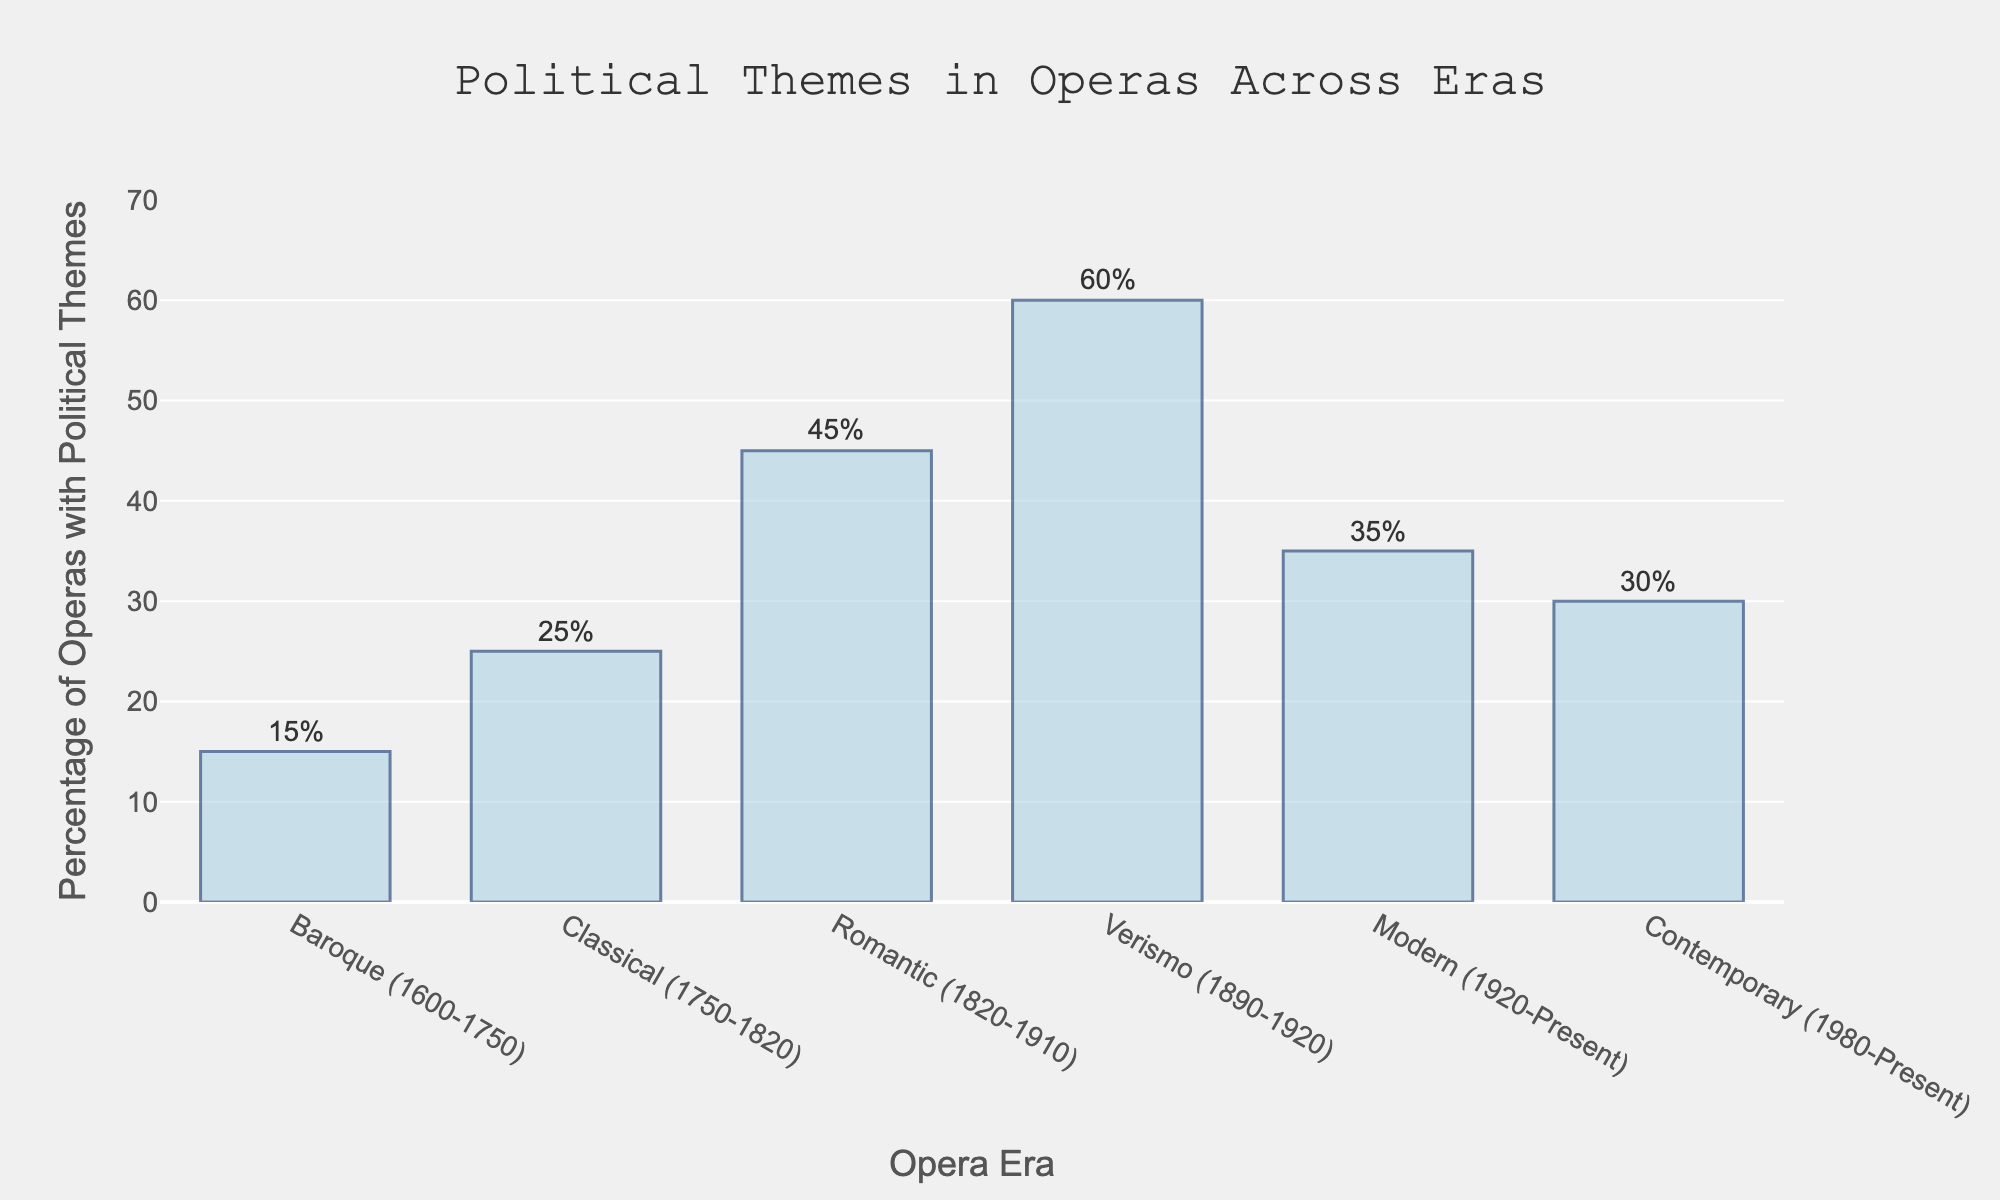Which era has the highest percentage of political themes in operas? The bar representing the Verismo era is the tallest, indicating the highest percentage of political themes in operas.
Answer: Verismo How much higher is the percentage of political themes in the Verismo era compared to the Baroque era? The Verismo era has 60%, and the Baroque era has 15%, so the difference is 60% - 15% = 45%.
Answer: 45% Which era has the lowest percentage of political themes in operas? The bar representing the Baroque era is the shortest, indicating the lowest percentage.
Answer: Baroque What is the average percentage of political themes in operas across all eras? Sum the percentages (15 + 25 + 45 + 60 + 35 + 30) = 210, then divide by the number of eras, which is 6. 210 / 6 = 35%.
Answer: 35% Which two eras have the closest percentages of political themes in operas? The Modern era (35%) and the Contemporary era (30%) bars are closest to each other. The difference is 35% - 30% = 5%.
Answer: Modern and Contemporary How much more frequent are political themes in the Romantic era compared to the Classical era? The Romantic era has 45%, and the Classical era has 25%, so the difference is 45% - 25% = 20%.
Answer: 20% Does the percentage of political themes in operas increase or decrease from the Romantic era to the Modern era? The Romantic era has 45%, and the Modern era has 35%, showing a decrease.
Answer: Decrease What is the median percentage of political themes in operas across all eras? The percentages are: 15, 25, 30, 35, 45, 60. With 6 values, the median is the average of the 3rd and 4th values, (30 + 35) / 2 = 32.5%.
Answer: 32.5% By how much does the percentage of political themes in operas change from the Verismo era to the Contemporary era? The Verismo era has 60%, and the Contemporary era has 30%, so the difference is 60% - 30% = 30%.
Answer: 30% What percentage of operas in the Modern era feature political themes? The bar for the Modern era indicates 35%.
Answer: 35% 